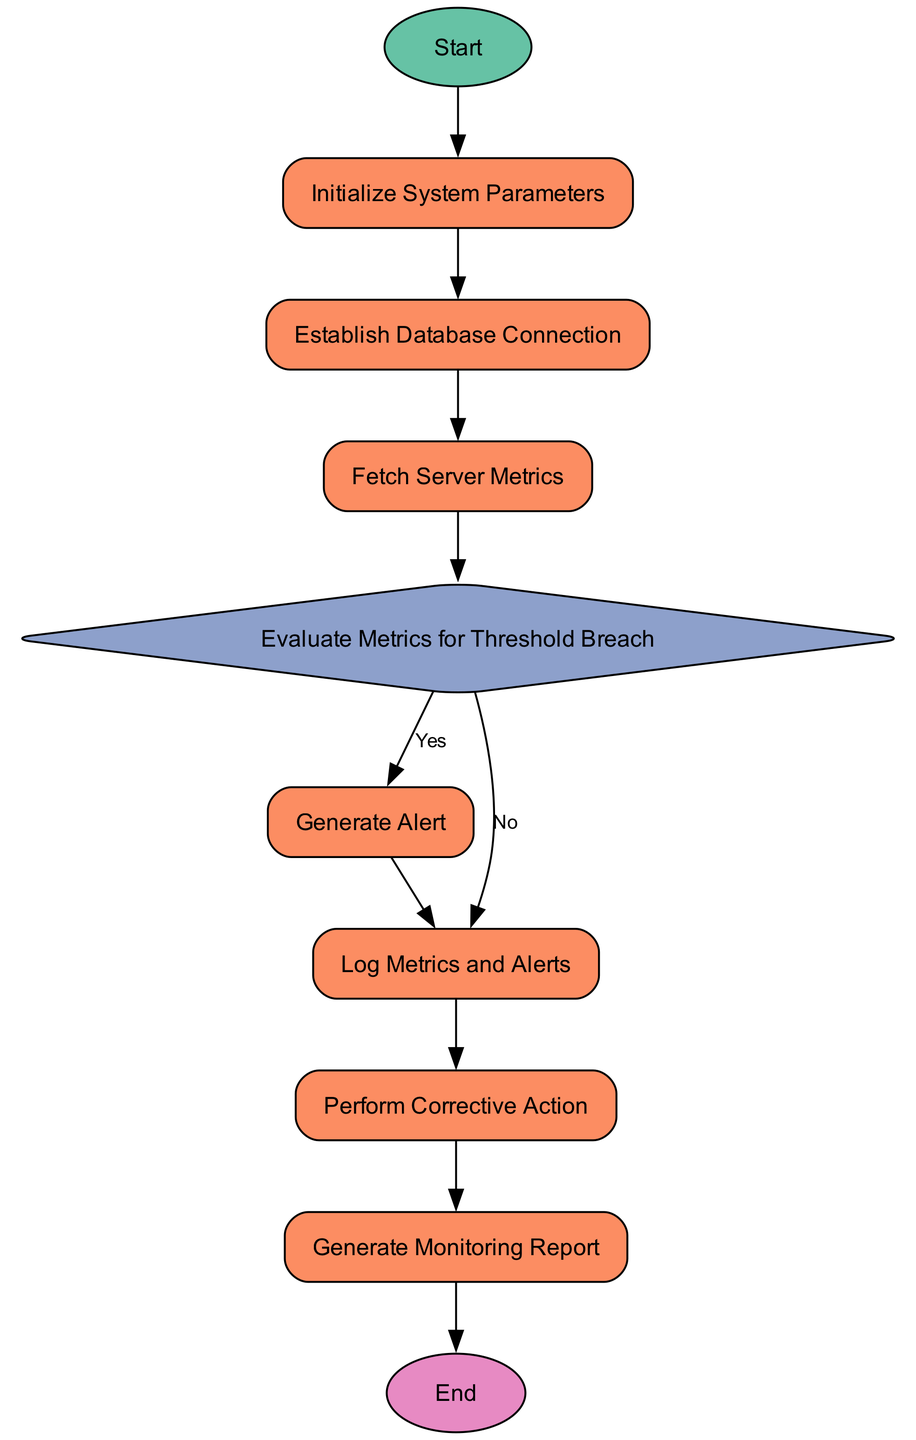What is the first process in the flowchart? The flowchart starts with the "Initialize System Parameters" process, which is the first process after the Start event.
Answer: Initialize System Parameters How many processes are there in total? By counting the elements categorizing them as 'Process', there are five processes in the flowchart that are part of the real-time monitoring and alerting system initiation sequence.
Answer: Five What happens if the metrics do not breach the thresholds? If the metrics collected do not exceed the predefined thresholds, the flowchart indicates that the process continues to "Log Metrics and Alerts," indicating that no alert is generated in this case.
Answer: Log Metrics and Alerts What is the last step before the End event? The last step before reaching the End event is "Generate Monitoring Report," which occurs right before concluding the flowchart.
Answer: Generate Monitoring Report What is the decision made in the flowchart? The decision made in the flowchart is to evaluate whether the collected metrics exceed predefined thresholds, determining the flow towards generating an alert or logging metrics without alerts.
Answer: Evaluate Metrics for Threshold Breach What are the two notification methods listed for alert generation? The alert generation process includes notifying via email and SMS, ensuring informed recipients about any breaches.
Answer: Email and SMS Which process follows the "Fetch Server Metrics" process? Following the "Fetch Server Metrics" process, the flowchart directs to the "Evaluate Metrics for Threshold Breach" process to determine if any thresholds have been breached.
Answer: Evaluate Metrics for Threshold Breach What is the purpose of the "Log Metrics and Alerts" process? The purpose of the "Log Metrics and Alerts" process is to insert metric and alert data into the monitoring database, which is crucial for future analysis and record keeping.
Answer: Insert metric and alert data into the monitoring database What action occurs if a threshold is breached? If a threshold is breached, the flow indicates that the next action is to "Generate Alert," where notifications are created and dispatched.
Answer: Generate Alert 